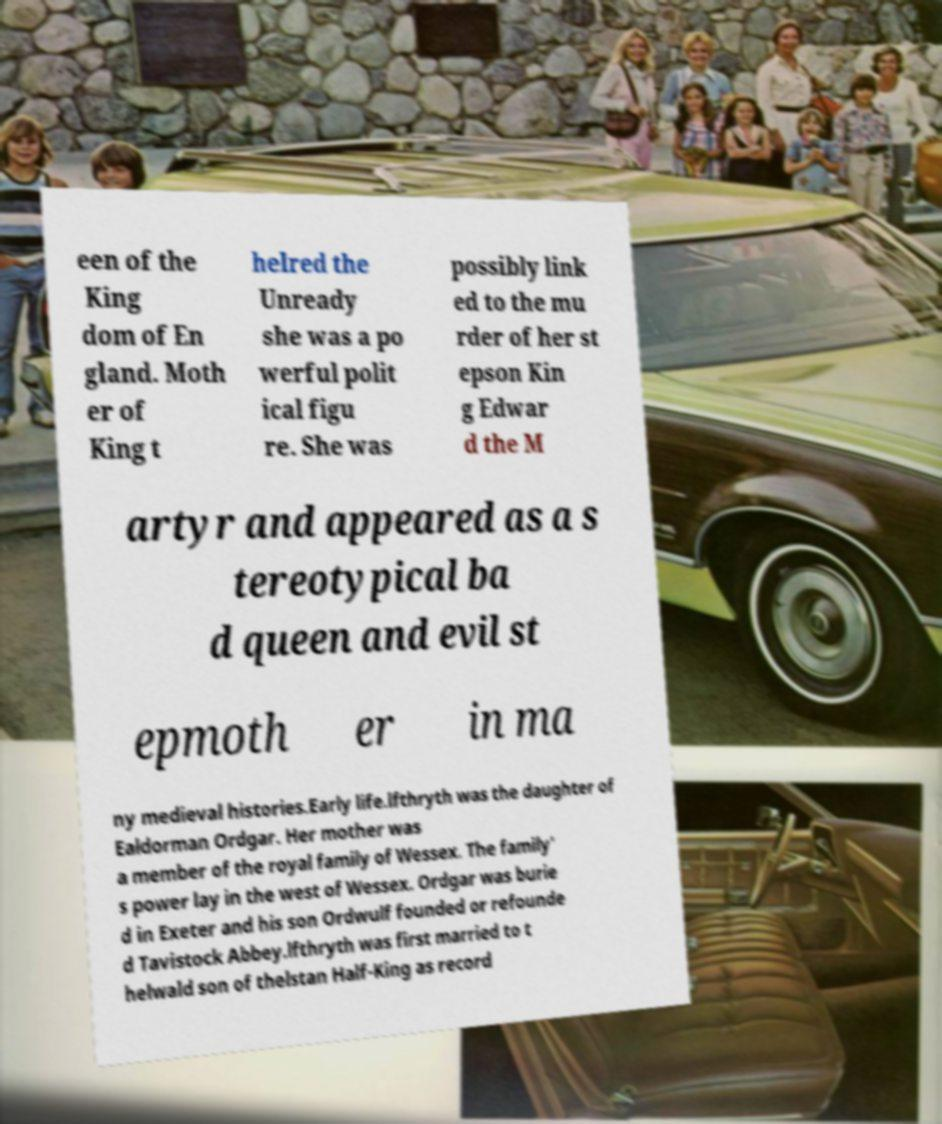Could you extract and type out the text from this image? een of the King dom of En gland. Moth er of King t helred the Unready she was a po werful polit ical figu re. She was possibly link ed to the mu rder of her st epson Kin g Edwar d the M artyr and appeared as a s tereotypical ba d queen and evil st epmoth er in ma ny medieval histories.Early life.lfthryth was the daughter of Ealdorman Ordgar. Her mother was a member of the royal family of Wessex. The family' s power lay in the west of Wessex. Ordgar was burie d in Exeter and his son Ordwulf founded or refounde d Tavistock Abbey.lfthryth was first married to t helwald son of thelstan Half-King as record 